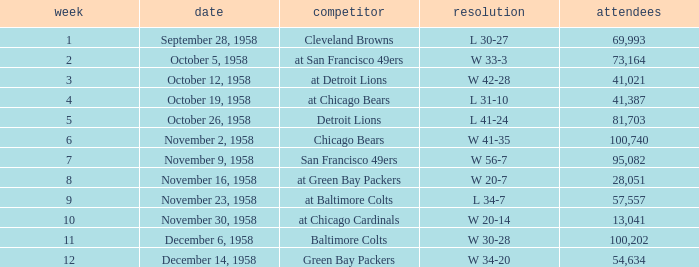What was the higest attendance on November 9, 1958? 95082.0. 